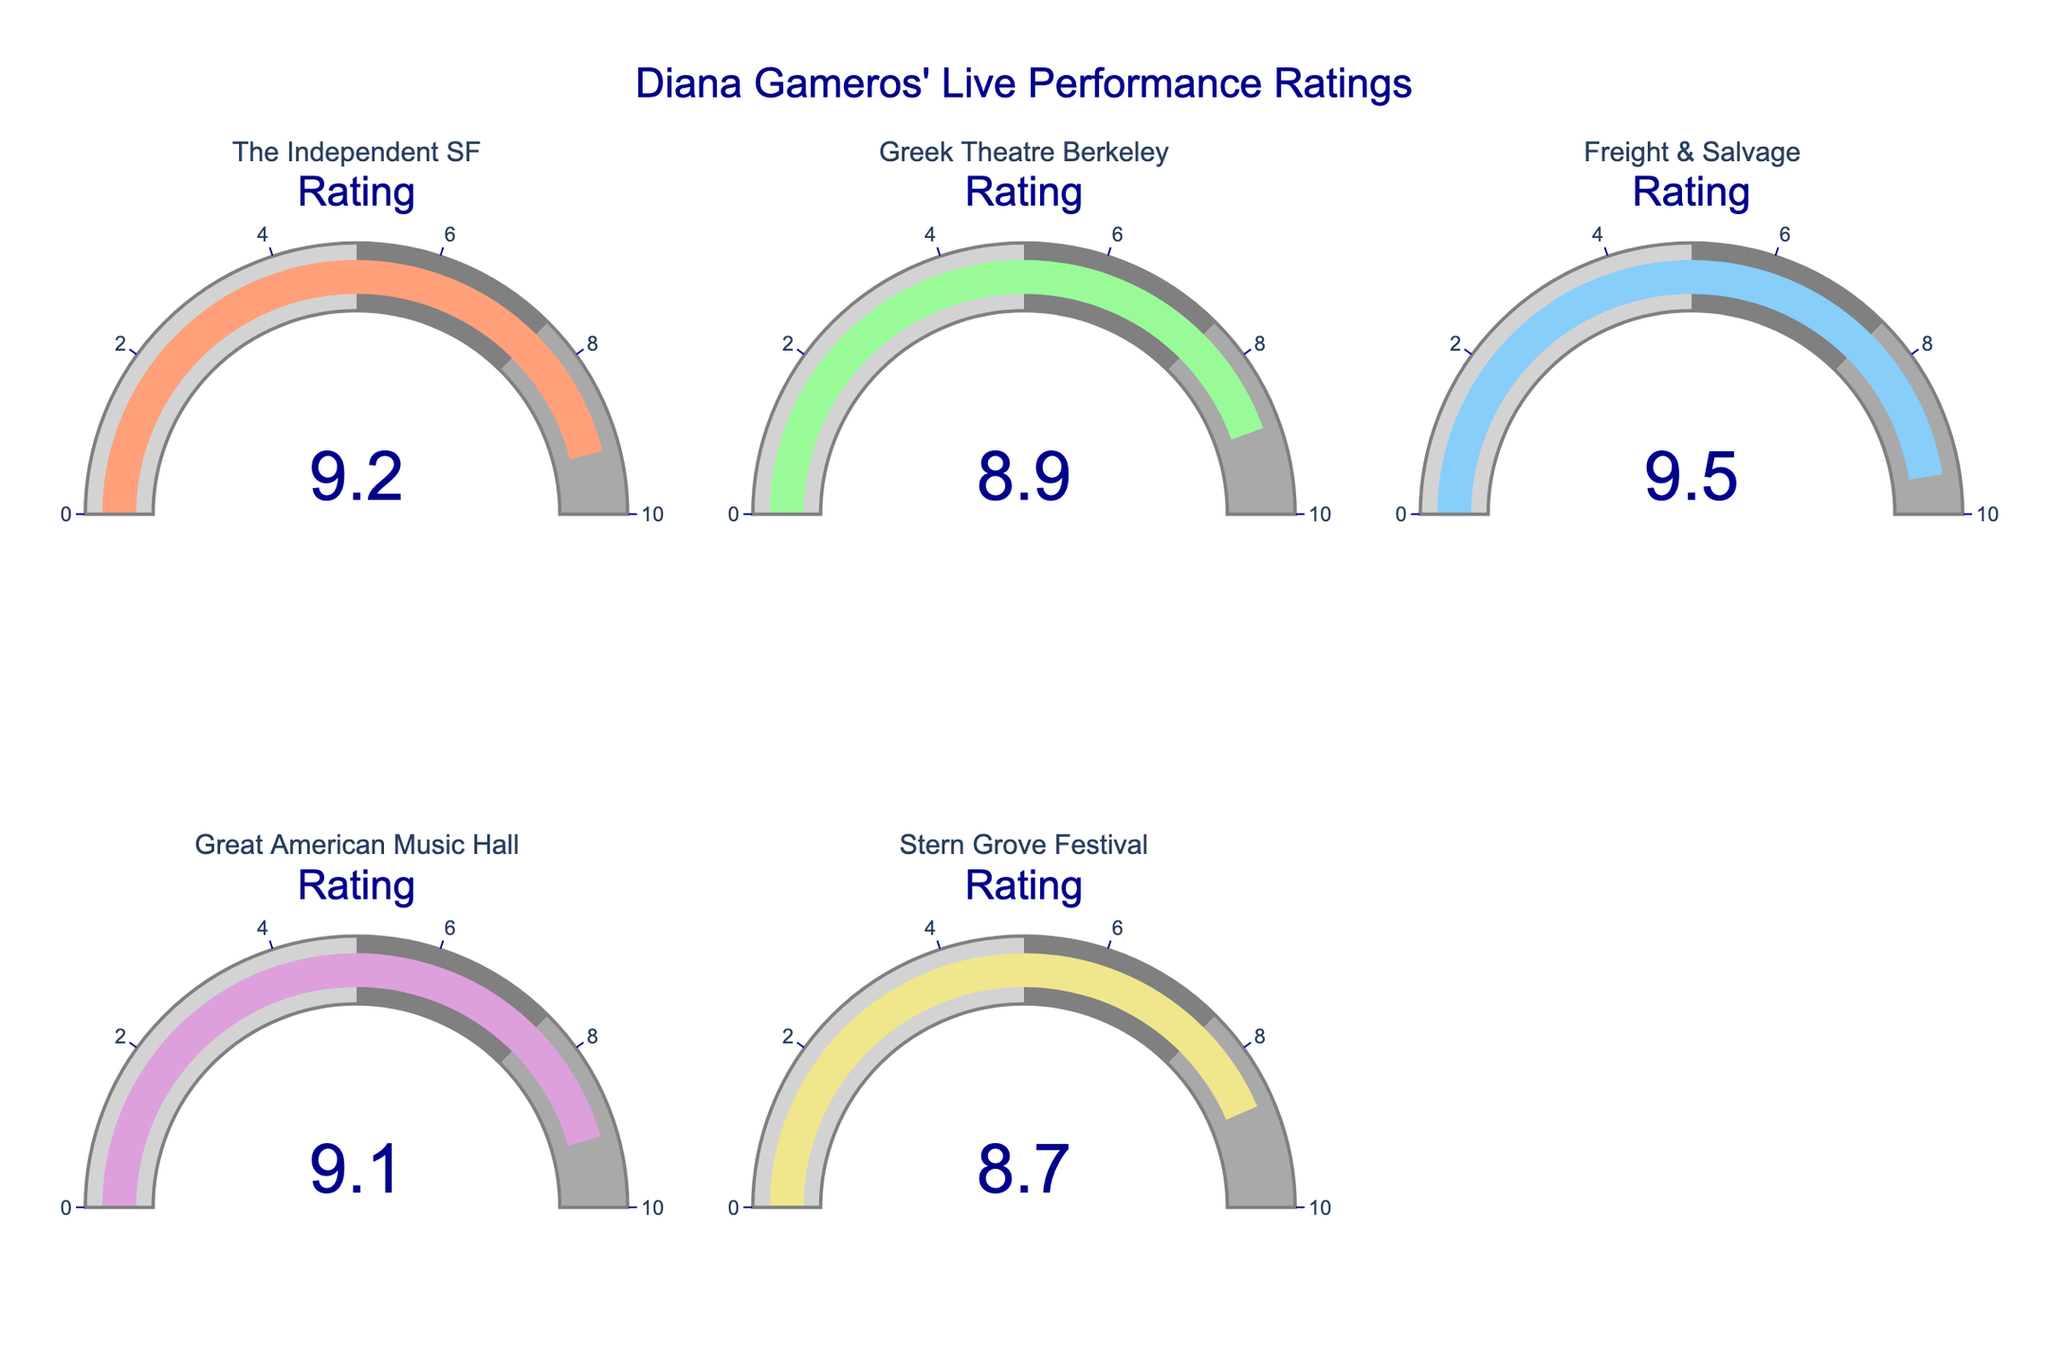What is the highest rating among all venues? Check each gauge chart to find the maximum value. The highest rating is 9.5 at Freight & Salvage.
Answer: 9.5 What is the lowest rating displayed on the gauges? Inspect the gauge charts to identify the lowest value. The lowest rating is 8.7 at Stern Grove Festival.
Answer: 8.7 What is the average rating of all venues combined? Sum all ratings: 9.2 + 8.9 + 9.5 + 9.1 + 8.7 = 45.4. Then divide by the number of venues: 45.4 / 5 = 9.08.
Answer: 9.08 Which venue has a rating of 8.9? Look at the gauge chart labeled with different venues to find the one displaying 8.9. It is the Greek Theatre in Berkeley.
Answer: Greek Theatre Berkeley By how much does the highest rating exceed the lowest rating? Subtract the lowest rating (8.7) from the highest rating (9.5): 9.5 - 8.7 = 0.8.
Answer: 0.8 How many venues have a rating above 9? Count the number of gauge charts with ratings above 9. There are three: The Independent SF, Freight & Salvage, and Great American Music Hall.
Answer: 3 Which two venues have the closest ratings? Compare the differences between each pair of ratings. The smallest difference is 0.1, between The Independent SF (9.2) and Great American Music Hall (9.1).
Answer: The Independent SF and Great American Music Hall Is there any venue with a rating below 8.5? Check each gauge chart to see if there is a rating below 8.5. There is none.
Answer: No 